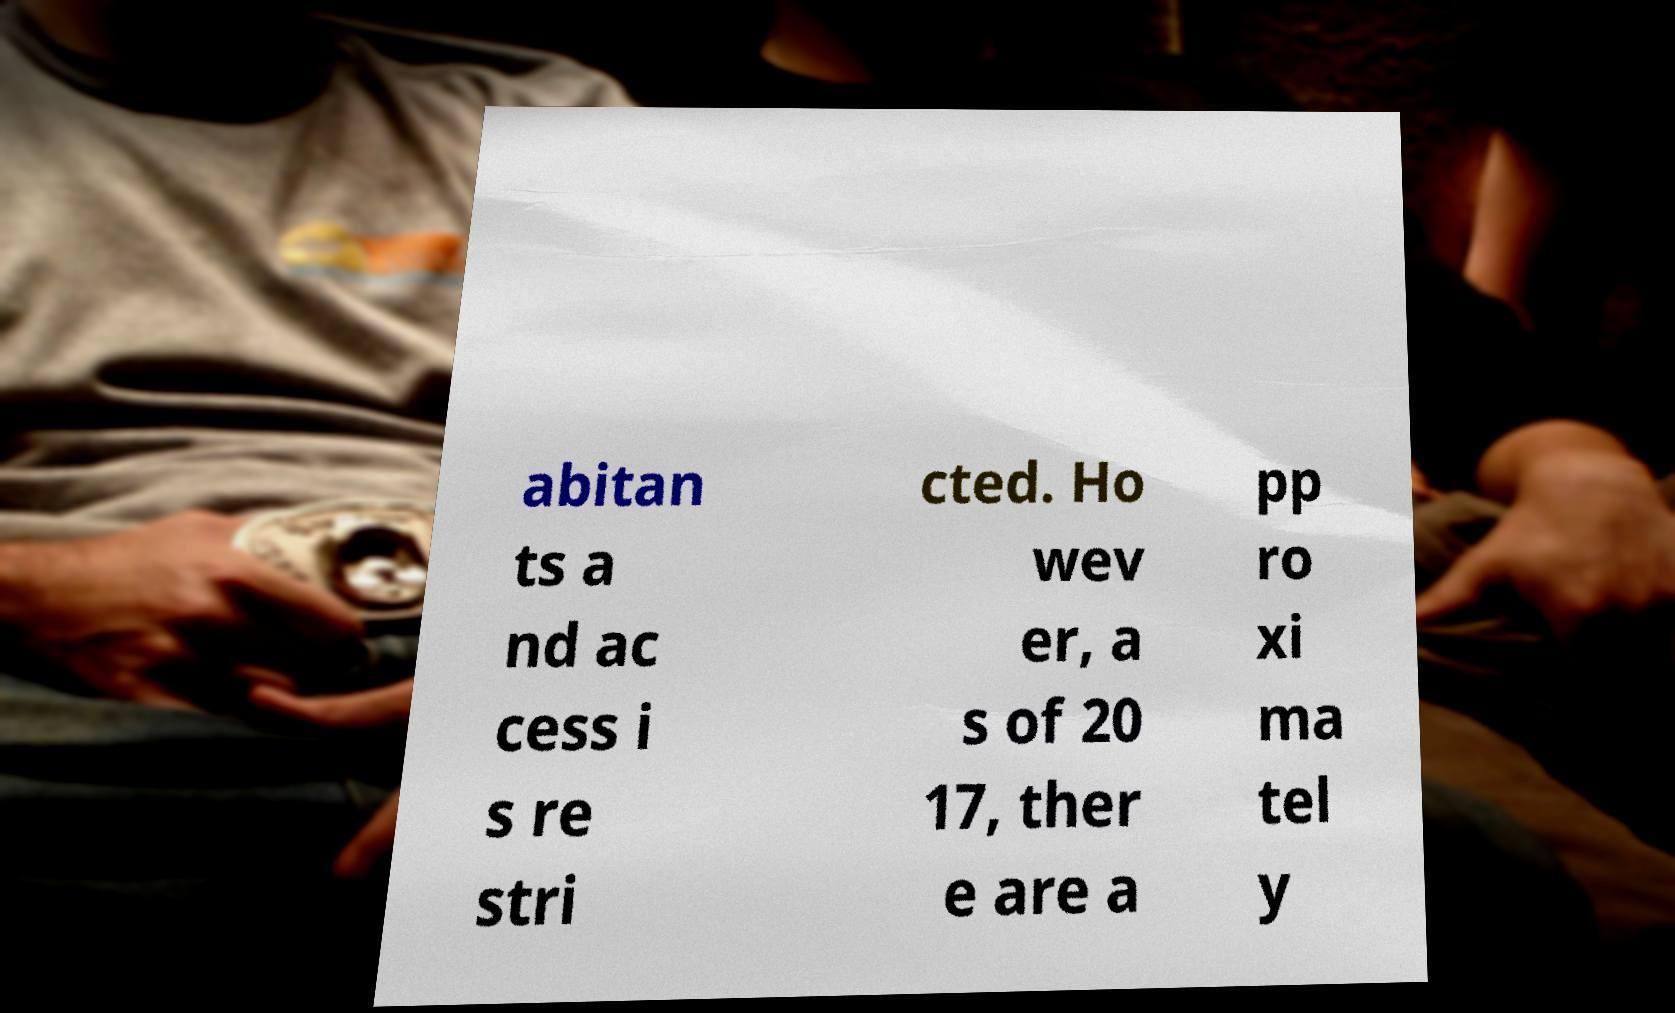What messages or text are displayed in this image? I need them in a readable, typed format. abitan ts a nd ac cess i s re stri cted. Ho wev er, a s of 20 17, ther e are a pp ro xi ma tel y 